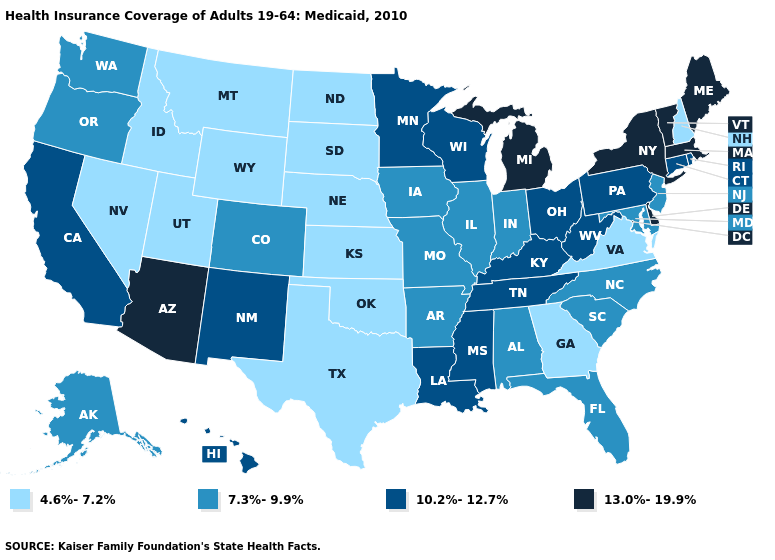What is the highest value in the South ?
Answer briefly. 13.0%-19.9%. Name the states that have a value in the range 4.6%-7.2%?
Write a very short answer. Georgia, Idaho, Kansas, Montana, Nebraska, Nevada, New Hampshire, North Dakota, Oklahoma, South Dakota, Texas, Utah, Virginia, Wyoming. Does the map have missing data?
Keep it brief. No. Does the map have missing data?
Write a very short answer. No. What is the highest value in states that border North Carolina?
Write a very short answer. 10.2%-12.7%. Does Oregon have the highest value in the USA?
Short answer required. No. Does Maine have the highest value in the USA?
Keep it brief. Yes. Among the states that border Indiana , which have the lowest value?
Give a very brief answer. Illinois. What is the value of Maine?
Short answer required. 13.0%-19.9%. Does Hawaii have the lowest value in the West?
Answer briefly. No. What is the value of Pennsylvania?
Short answer required. 10.2%-12.7%. What is the value of Iowa?
Short answer required. 7.3%-9.9%. Which states have the highest value in the USA?
Give a very brief answer. Arizona, Delaware, Maine, Massachusetts, Michigan, New York, Vermont. Which states have the lowest value in the Northeast?
Give a very brief answer. New Hampshire. What is the value of New York?
Be succinct. 13.0%-19.9%. 